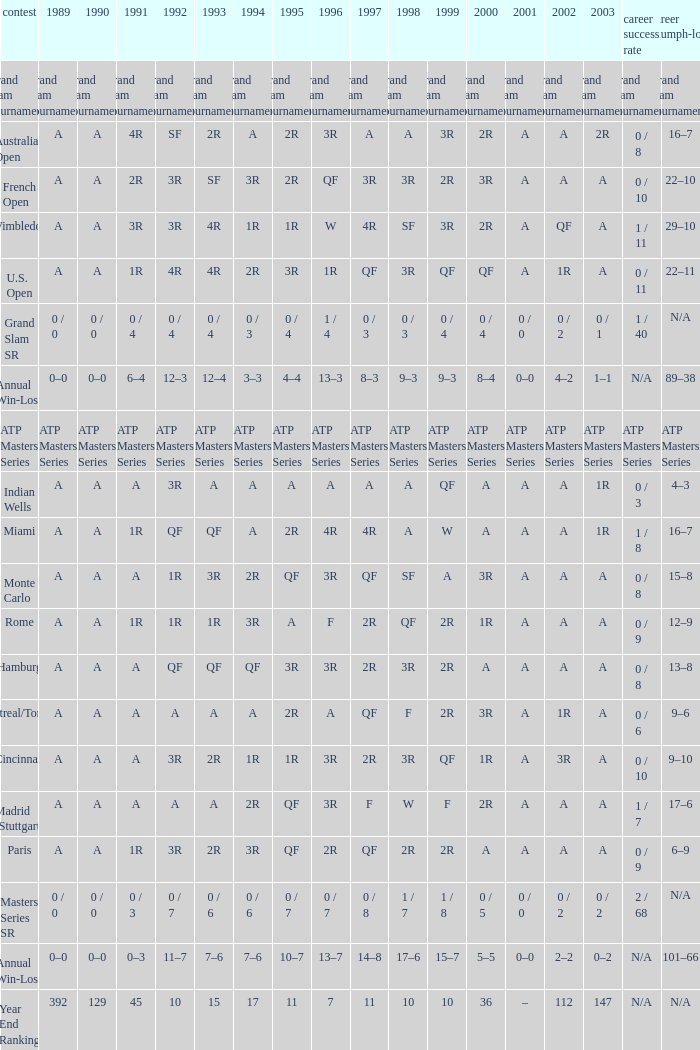What was the value in 1995 for A in 2000 at the Indian Wells tournament? A. 